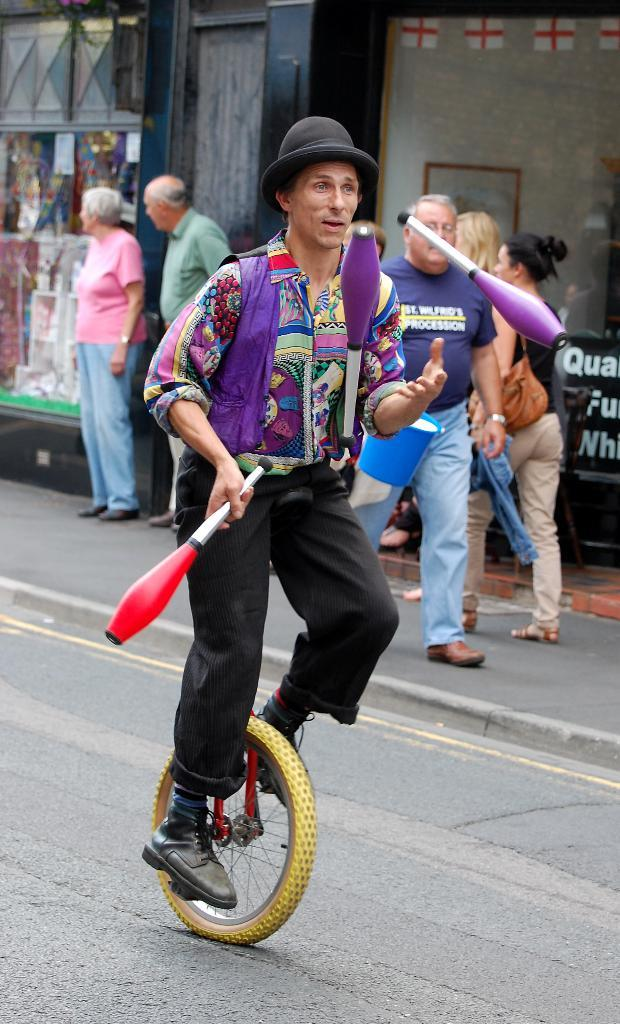What is the main subject of the image? The main subject of the image is a person riding a cycle. What is the person doing while riding the cycle? The person is juggling while riding the cycle. What can be seen in the background of the image? There are people walking on the sidewalk and buildings visible in the background. How many children are wishing on a question in the image? There are no children or questions present in the image. 